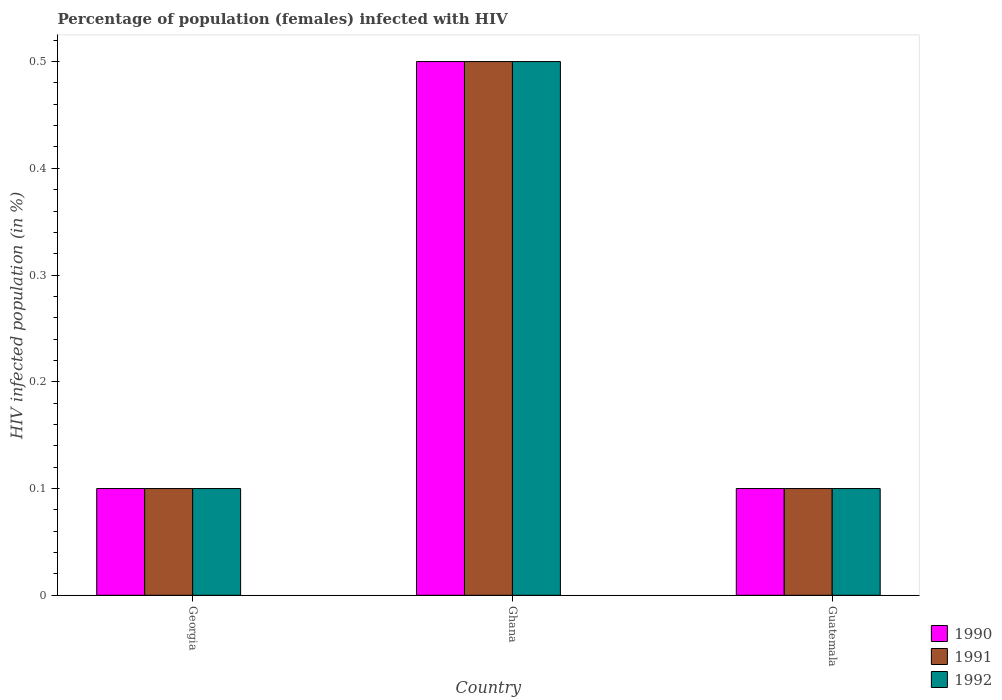How many groups of bars are there?
Provide a short and direct response. 3. What is the label of the 1st group of bars from the left?
Keep it short and to the point. Georgia. Across all countries, what is the minimum percentage of HIV infected female population in 1991?
Provide a succinct answer. 0.1. In which country was the percentage of HIV infected female population in 1991 maximum?
Provide a succinct answer. Ghana. In which country was the percentage of HIV infected female population in 1990 minimum?
Provide a short and direct response. Georgia. What is the total percentage of HIV infected female population in 1990 in the graph?
Provide a succinct answer. 0.7. What is the difference between the percentage of HIV infected female population in 1990 in Georgia and that in Guatemala?
Give a very brief answer. 0. What is the difference between the percentage of HIV infected female population in 1991 in Georgia and the percentage of HIV infected female population in 1990 in Guatemala?
Your answer should be compact. 0. What is the average percentage of HIV infected female population in 1992 per country?
Ensure brevity in your answer.  0.23. Is the percentage of HIV infected female population in 1991 in Ghana less than that in Guatemala?
Provide a succinct answer. No. Is the difference between the percentage of HIV infected female population in 1991 in Georgia and Guatemala greater than the difference between the percentage of HIV infected female population in 1992 in Georgia and Guatemala?
Ensure brevity in your answer.  No. What is the difference between the highest and the second highest percentage of HIV infected female population in 1990?
Offer a terse response. 0.4. What does the 3rd bar from the left in Ghana represents?
Offer a very short reply. 1992. How many bars are there?
Keep it short and to the point. 9. Does the graph contain any zero values?
Your answer should be very brief. No. Where does the legend appear in the graph?
Keep it short and to the point. Bottom right. How many legend labels are there?
Offer a terse response. 3. What is the title of the graph?
Your answer should be very brief. Percentage of population (females) infected with HIV. Does "2010" appear as one of the legend labels in the graph?
Give a very brief answer. No. What is the label or title of the X-axis?
Keep it short and to the point. Country. What is the label or title of the Y-axis?
Offer a very short reply. HIV infected population (in %). What is the HIV infected population (in %) in 1990 in Georgia?
Your response must be concise. 0.1. What is the HIV infected population (in %) in 1991 in Georgia?
Your response must be concise. 0.1. What is the HIV infected population (in %) of 1990 in Ghana?
Make the answer very short. 0.5. What is the HIV infected population (in %) in 1992 in Ghana?
Provide a short and direct response. 0.5. What is the HIV infected population (in %) of 1990 in Guatemala?
Offer a terse response. 0.1. What is the HIV infected population (in %) in 1991 in Guatemala?
Provide a succinct answer. 0.1. Across all countries, what is the maximum HIV infected population (in %) in 1991?
Your answer should be very brief. 0.5. Across all countries, what is the maximum HIV infected population (in %) of 1992?
Provide a short and direct response. 0.5. Across all countries, what is the minimum HIV infected population (in %) in 1992?
Your answer should be very brief. 0.1. What is the total HIV infected population (in %) in 1991 in the graph?
Make the answer very short. 0.7. What is the difference between the HIV infected population (in %) of 1990 in Georgia and that in Ghana?
Keep it short and to the point. -0.4. What is the difference between the HIV infected population (in %) in 1992 in Georgia and that in Guatemala?
Give a very brief answer. 0. What is the difference between the HIV infected population (in %) of 1992 in Ghana and that in Guatemala?
Your response must be concise. 0.4. What is the difference between the HIV infected population (in %) in 1990 in Georgia and the HIV infected population (in %) in 1992 in Ghana?
Your response must be concise. -0.4. What is the difference between the HIV infected population (in %) of 1991 in Georgia and the HIV infected population (in %) of 1992 in Ghana?
Offer a terse response. -0.4. What is the difference between the HIV infected population (in %) in 1990 in Georgia and the HIV infected population (in %) in 1991 in Guatemala?
Your response must be concise. 0. What is the difference between the HIV infected population (in %) in 1990 in Georgia and the HIV infected population (in %) in 1992 in Guatemala?
Provide a short and direct response. 0. What is the difference between the HIV infected population (in %) in 1990 in Ghana and the HIV infected population (in %) in 1991 in Guatemala?
Your response must be concise. 0.4. What is the difference between the HIV infected population (in %) of 1990 in Ghana and the HIV infected population (in %) of 1992 in Guatemala?
Ensure brevity in your answer.  0.4. What is the difference between the HIV infected population (in %) in 1991 in Ghana and the HIV infected population (in %) in 1992 in Guatemala?
Your answer should be very brief. 0.4. What is the average HIV infected population (in %) in 1990 per country?
Your response must be concise. 0.23. What is the average HIV infected population (in %) in 1991 per country?
Your answer should be compact. 0.23. What is the average HIV infected population (in %) of 1992 per country?
Provide a succinct answer. 0.23. What is the difference between the HIV infected population (in %) in 1990 and HIV infected population (in %) in 1992 in Georgia?
Offer a terse response. 0. What is the difference between the HIV infected population (in %) of 1990 and HIV infected population (in %) of 1992 in Ghana?
Offer a very short reply. 0. What is the difference between the HIV infected population (in %) in 1991 and HIV infected population (in %) in 1992 in Guatemala?
Give a very brief answer. 0. What is the difference between the highest and the second highest HIV infected population (in %) in 1990?
Ensure brevity in your answer.  0.4. What is the difference between the highest and the second highest HIV infected population (in %) of 1992?
Keep it short and to the point. 0.4. What is the difference between the highest and the lowest HIV infected population (in %) in 1990?
Give a very brief answer. 0.4. What is the difference between the highest and the lowest HIV infected population (in %) in 1992?
Offer a very short reply. 0.4. 